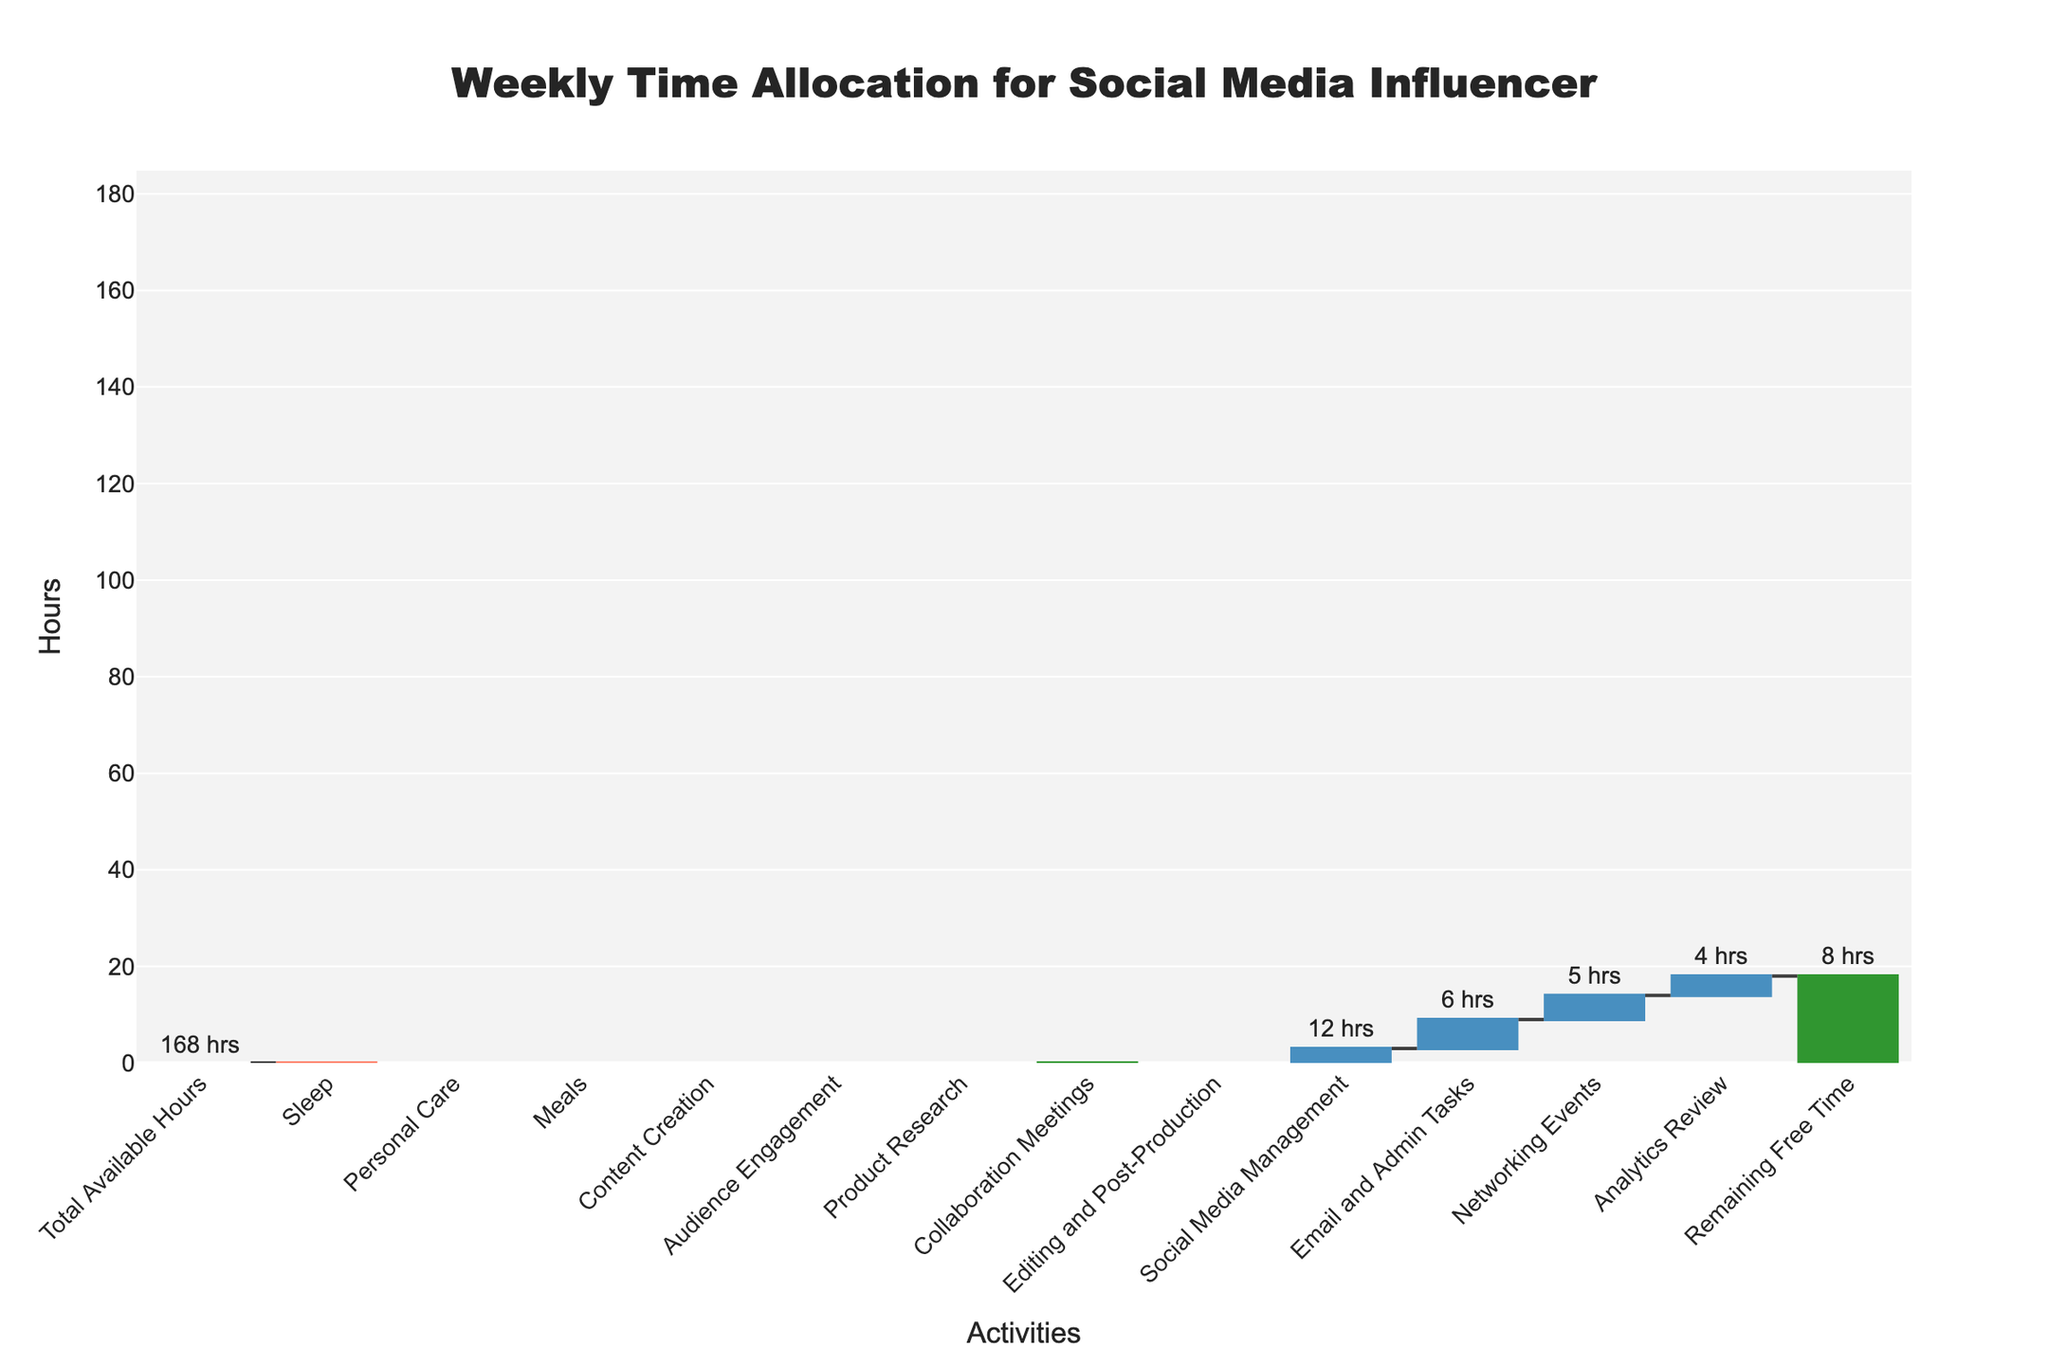What is the total number of hours available in a week? The title and the first bar in the waterfall chart indicate that the total available hours in a week are 168. This value is labeled on the chart and serves as the starting point for other activities.
Answer: 168 How many hours are dedicated to sleep? The second bar in the waterfall chart labeled "Sleep" shows the number of hours dedicated to sleeping each week. The negative value indicates a deduction from total available hours.
Answer: 56 What is the combined time allocated for Content Creation and Audience Engagement? Identify the individual bars for "Content Creation" and "Audience Engagement," then add their hours together (30 + 20).
Answer: 50 Which activity has the highest time contribution besides sleep? Scan the bars to find the one with the most significant positive height, aside from the "Sleep" bar. The "Content Creation" bar at 30 hours stands out.
Answer: Content Creation How much free time remains after all other activities? The last bar in the chart labeled "Remaining Free Time" provides this information, which is directly visible on the chart.
Answer: 8 What is the difference between the time spent on Editing and Post-Production and Social Media Management? Subtract the hours allocated to "Social Media Management" from those allocated to "Editing and Post-Production" (15 - 12).
Answer: 3 Which activities have a direct negative impact on the total time available? Identify all activities represented by negative bars in the chart: Sleep, Personal Care, and Meals.
Answer: Sleep, Personal Care, Meals How many hours are allocated to activities related to managing the influencer's social media presence? Combine the hours dedicated to "Social Media Management" and "Audience Engagement" (12 + 20).
Answer: 32 What is the relative time difference between Collaboration Meetings and Product Research? Subtract the hours allocated to "Product Research" from "Collaboration Meetings" (10 - 8).
Answer: 2 How many total hours are occupied by non-work-related activities? Sum the hours allocated to "Sleep," "Personal Care," and "Meals" (56 + 14 + 14).
Answer: 84 